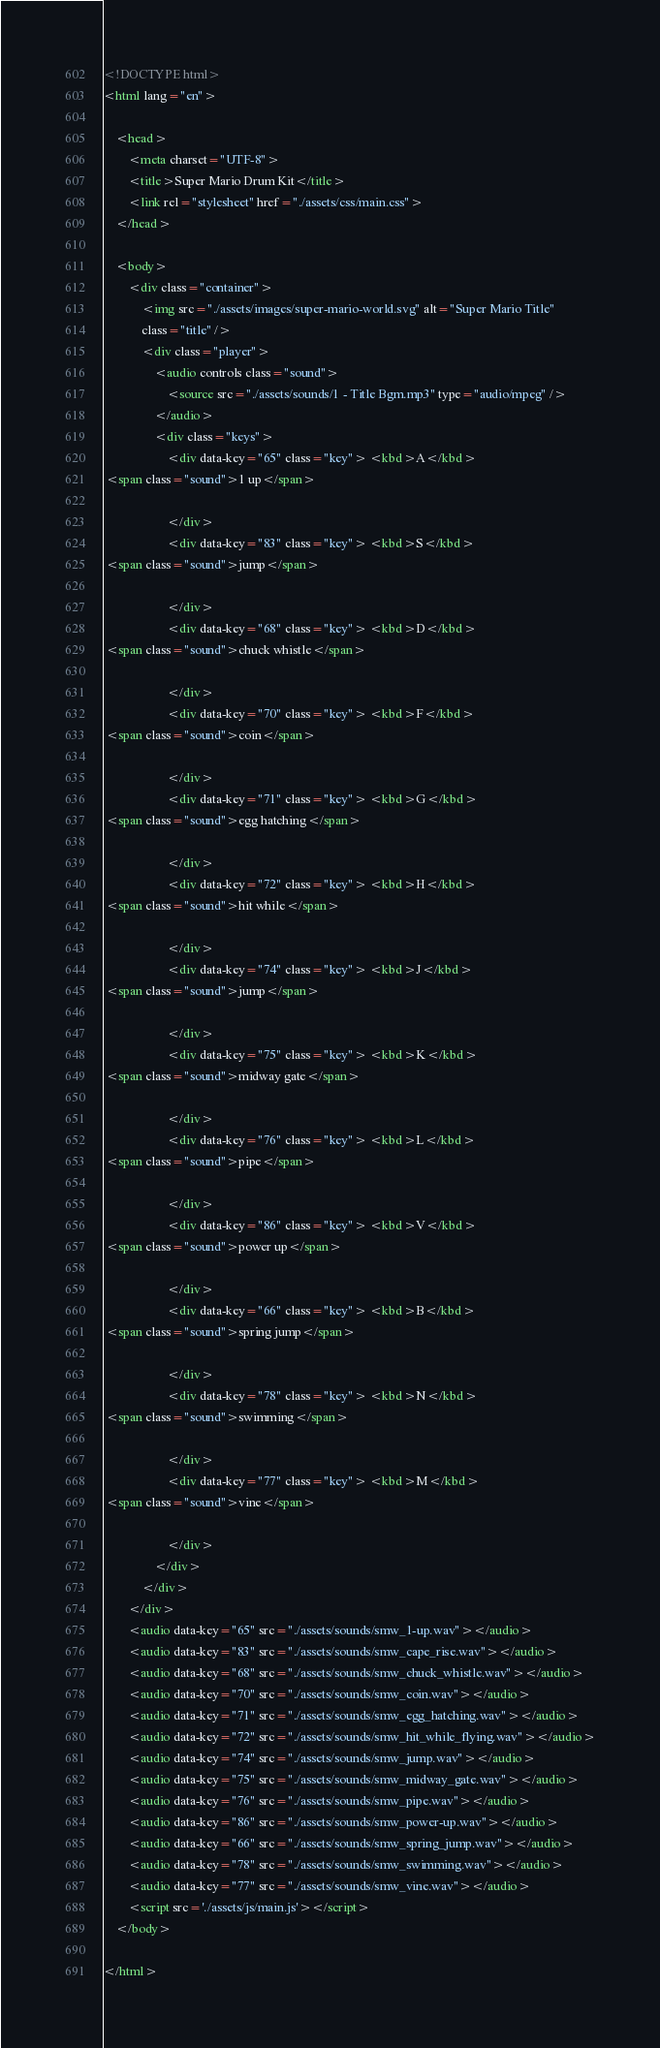<code> <loc_0><loc_0><loc_500><loc_500><_HTML_><!DOCTYPE html>
<html lang="en">
    
    <head>
        <meta charset="UTF-8">
        <title>Super Mario Drum Kit</title>
        <link rel="stylesheet" href="./assets/css/main.css">
    </head>
    
    <body>
        <div class="container">
            <img src="./assets/images/super-mario-world.svg" alt="Super Mario Title"
            class="title" />
            <div class="player">
                <audio controls class="sound">
                    <source src="./assets/sounds/1 - Title Bgm.mp3" type="audio/mpeg" />
                </audio>
                <div class="keys">
                    <div data-key="65" class="key"> <kbd>A</kbd>
 <span class="sound">1 up</span>

                    </div>
                    <div data-key="83" class="key"> <kbd>S</kbd>
 <span class="sound">jump</span>

                    </div>
                    <div data-key="68" class="key"> <kbd>D</kbd>
 <span class="sound">chuck whistle</span>

                    </div>
                    <div data-key="70" class="key"> <kbd>F</kbd>
 <span class="sound">coin</span>

                    </div>
                    <div data-key="71" class="key"> <kbd>G</kbd>
 <span class="sound">egg hatching</span>

                    </div>
                    <div data-key="72" class="key"> <kbd>H</kbd>
 <span class="sound">hit while</span>

                    </div>
                    <div data-key="74" class="key"> <kbd>J</kbd>
 <span class="sound">jump</span>

                    </div>
                    <div data-key="75" class="key"> <kbd>K</kbd>
 <span class="sound">midway gate</span>

                    </div>
                    <div data-key="76" class="key"> <kbd>L</kbd>
 <span class="sound">pipe</span>

                    </div>
                    <div data-key="86" class="key"> <kbd>V</kbd>
 <span class="sound">power up</span>

                    </div>
                    <div data-key="66" class="key"> <kbd>B</kbd>
 <span class="sound">spring jump</span>

                    </div>
                    <div data-key="78" class="key"> <kbd>N</kbd>
 <span class="sound">swimming</span>

                    </div>
                    <div data-key="77" class="key"> <kbd>M</kbd>
 <span class="sound">vine</span>

                    </div>
                </div>
            </div>
        </div>
        <audio data-key="65" src="./assets/sounds/smw_1-up.wav"></audio>
        <audio data-key="83" src="./assets/sounds/smw_cape_rise.wav"></audio>
        <audio data-key="68" src="./assets/sounds/smw_chuck_whistle.wav"></audio>
        <audio data-key="70" src="./assets/sounds/smw_coin.wav"></audio>
        <audio data-key="71" src="./assets/sounds/smw_egg_hatching.wav"></audio>
        <audio data-key="72" src="./assets/sounds/smw_hit_while_flying.wav"></audio>
        <audio data-key="74" src="./assets/sounds/smw_jump.wav"></audio>
        <audio data-key="75" src="./assets/sounds/smw_midway_gate.wav"></audio>
        <audio data-key="76" src="./assets/sounds/smw_pipe.wav"></audio>
        <audio data-key="86" src="./assets/sounds/smw_power-up.wav"></audio>
        <audio data-key="66" src="./assets/sounds/smw_spring_jump.wav"></audio>
        <audio data-key="78" src="./assets/sounds/smw_swimming.wav"></audio>
        <audio data-key="77" src="./assets/sounds/smw_vine.wav"></audio>
        <script src='./assets/js/main.js'></script>
    </body>

</html></code> 